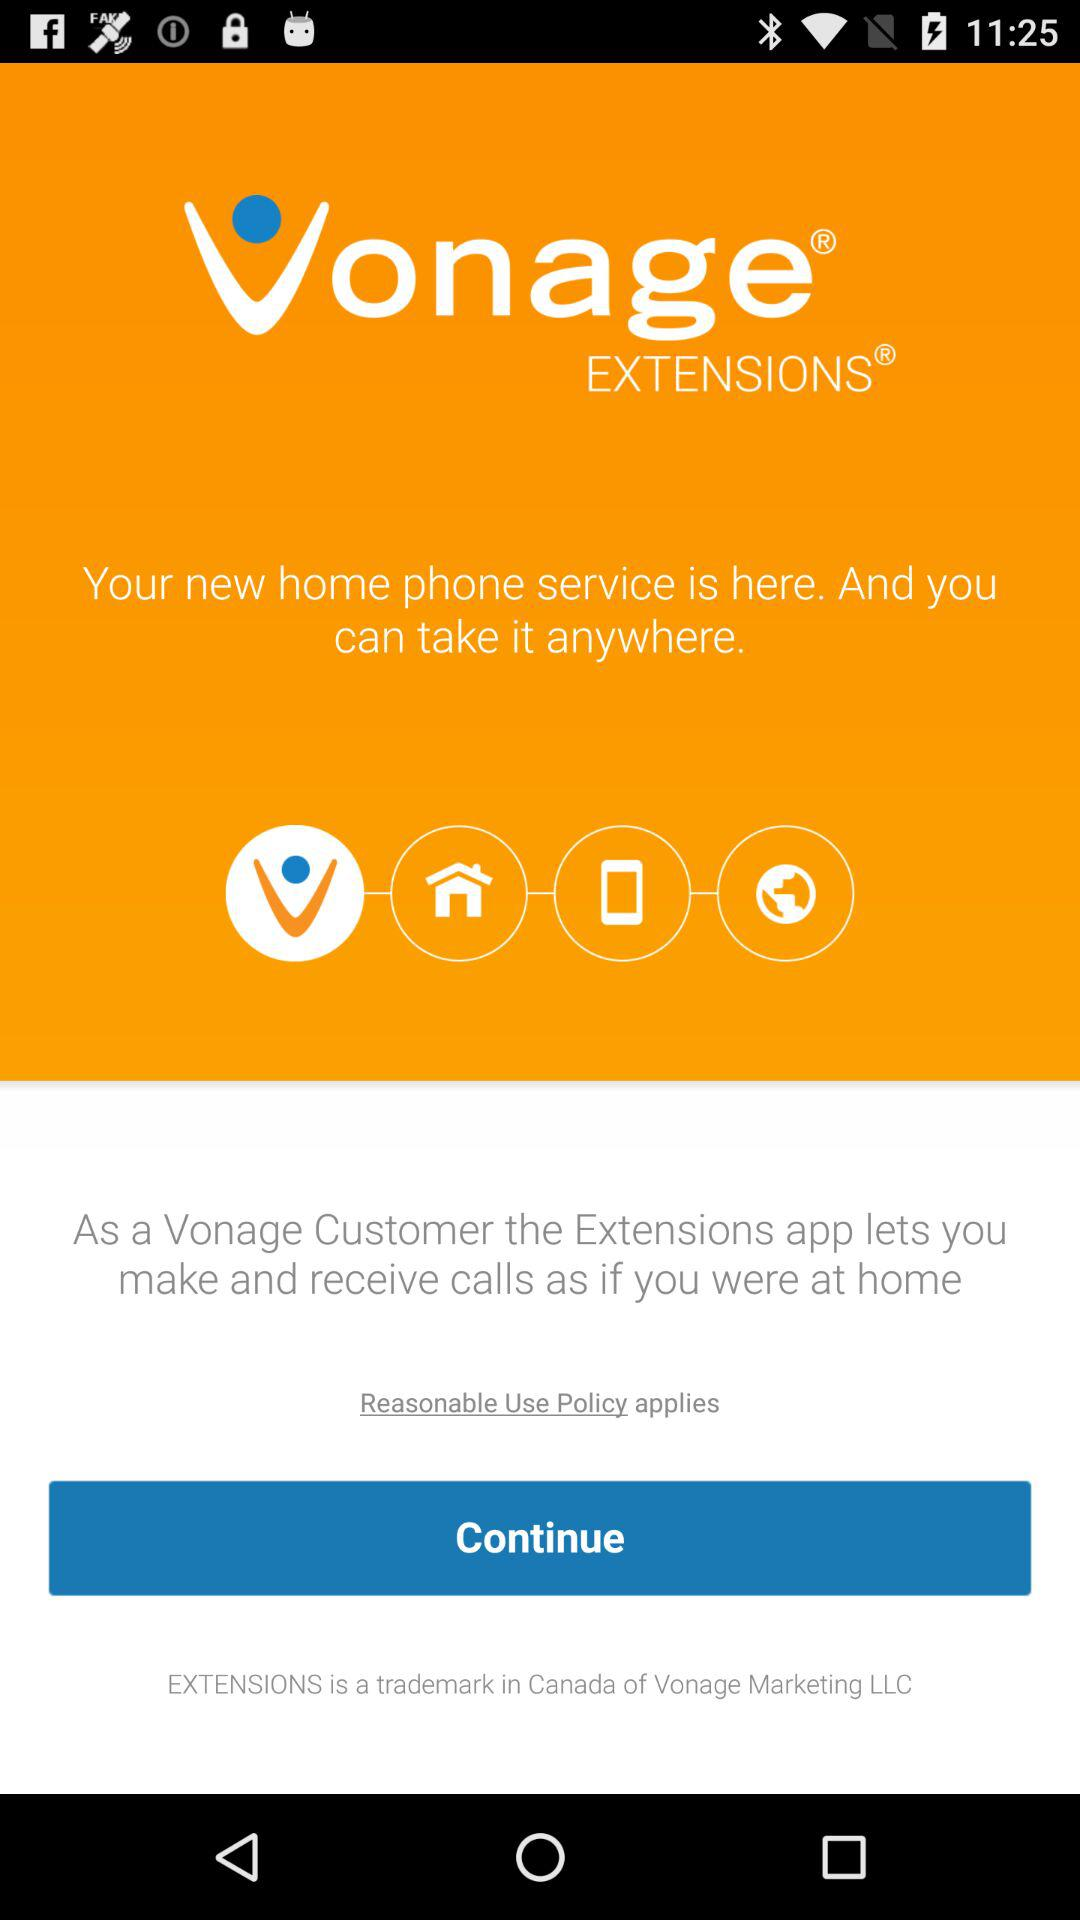What are the new home phone services?
When the provided information is insufficient, respond with <no answer>. <no answer> 